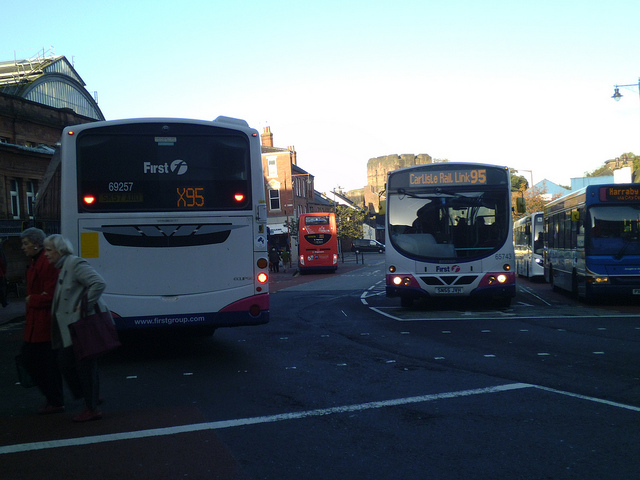Identify the text displayed in this image. 69257 x95 First Karrab Link Carlist www firstgroup com 95 Pail 65743 